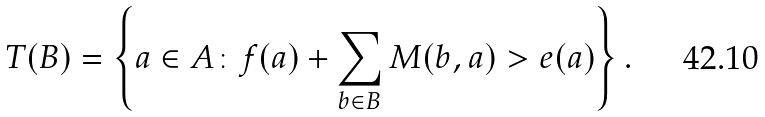Convert formula to latex. <formula><loc_0><loc_0><loc_500><loc_500>T ( B ) = \left \{ a \in A \colon f ( a ) + \sum _ { b \in B } M ( b , a ) > e ( a ) \right \} .</formula> 